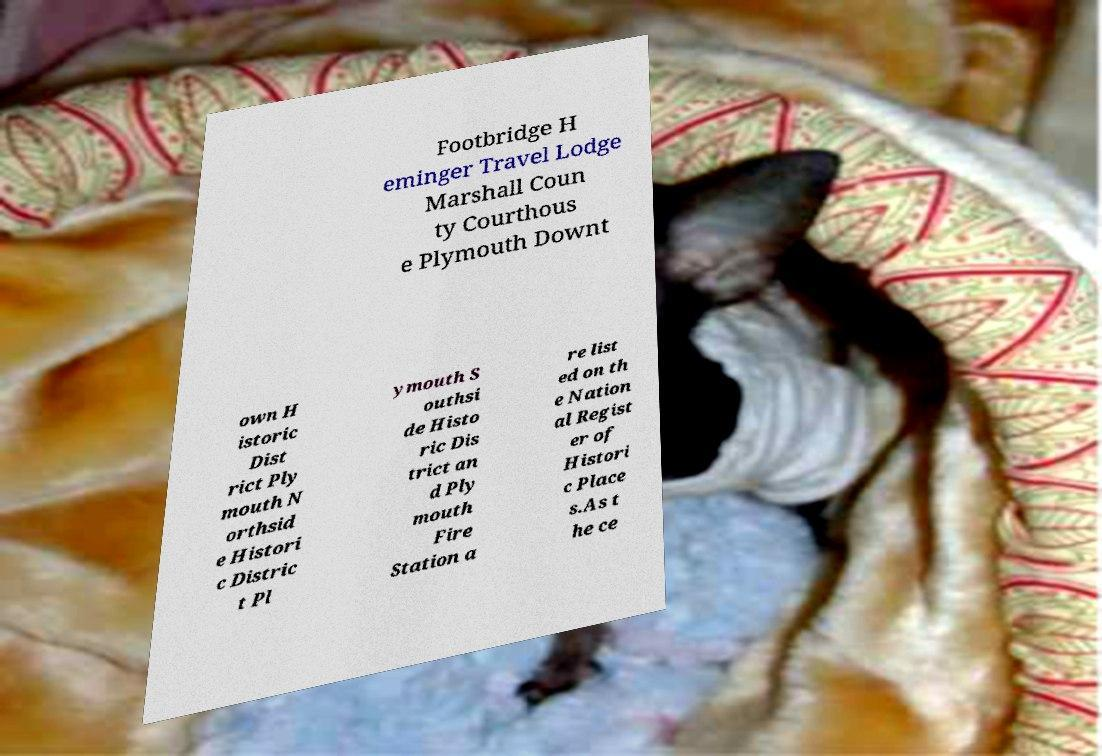Can you read and provide the text displayed in the image?This photo seems to have some interesting text. Can you extract and type it out for me? Footbridge H eminger Travel Lodge Marshall Coun ty Courthous e Plymouth Downt own H istoric Dist rict Ply mouth N orthsid e Histori c Distric t Pl ymouth S outhsi de Histo ric Dis trict an d Ply mouth Fire Station a re list ed on th e Nation al Regist er of Histori c Place s.As t he ce 